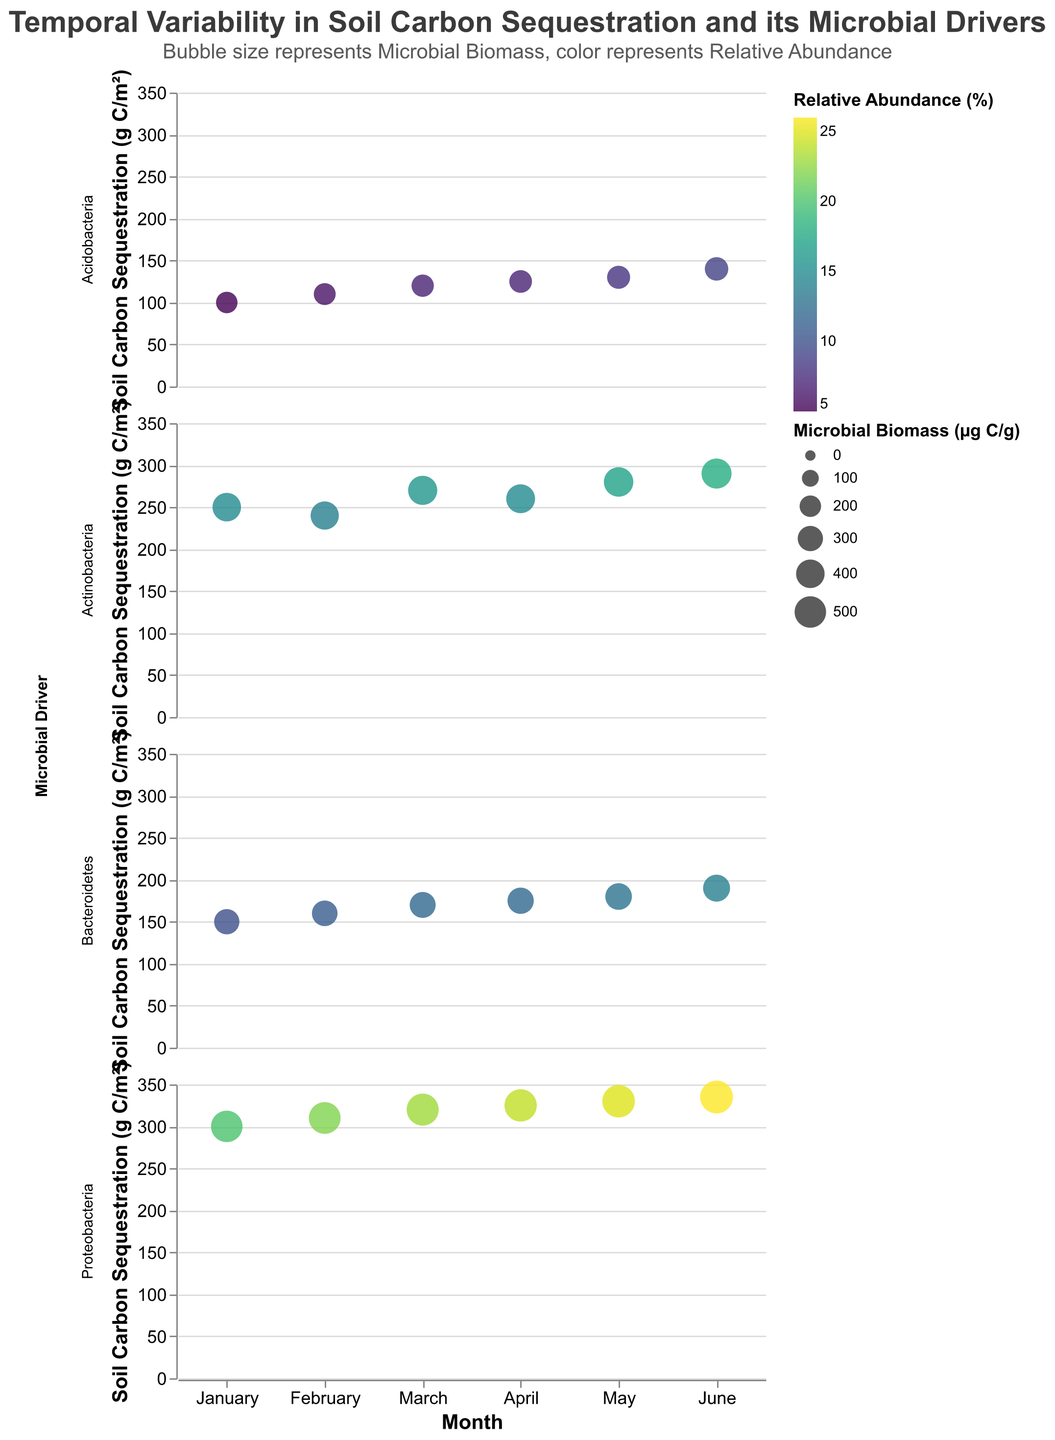What is the title of the figure? The title is prominently placed at the top of the figure. It reads "Temporal Variability in Soil Carbon Sequestration and its Microbial Drivers".
Answer: Temporal Variability in Soil Carbon Sequestration and its Microbial Drivers How is microbial biomass represented in the figure? Microbial biomass is represented by the size of the bubbles in each subplot. Larger bubbles indicate higher microbial biomass values.
Answer: Size of the bubbles Which microbial driver shows the highest soil carbon sequestration in June? By looking at the uppermost points on the y-axis (Soil Carbon Sequestration), the Proteobacteria subplot has the highest point in June, indicating the highest soil carbon sequestration.
Answer: Proteobacteria What is the range of the relative abundance percentage in this figure? The legend for color coding indicates that the relative abundance ranges from 5% to 26%. This range is spanned by the color gradient, from the lightest to the darkest shade.
Answer: 5% to 26% What months show an increase in soil carbon sequestration for Bacteroidetes? By observing the Bacteroidetes subplot, soil carbon sequestration values increase monthly from January through June. The values for each month are 150, 160, 170, 175, 180, and 190 g C/m² respectively.
Answer: January to June Compare the soil carbon sequestration of Actinobacteria and Acidobacteria in March. In March, Actinobacteria has a soil carbon sequestration of 270 g C/m², while Acidobacteria has a value of 120 g C/m². Actinobacteria has a higher value.
Answer: Actinobacteria What is the average soil carbon sequestration for Proteobacteria across all months? Add the soil carbon sequestration values for each month for Proteobacteria (300, 310, 320, 325, 330, 335) which sums to 1920 g C/m². Divide by 6 months to find the average (1920/6).
Answer: 320 g C/m² Which microbial driver has the least variation in relative abundance over the months? By observing the color consistency of the bubbles, Acidobacteria appears to have the least variation in color over the months, indicating minimal relative abundance variation.
Answer: Acidobacteria Explain the relationship between microbial biomass and soil carbon sequestration for Actinobacteria. For Actinobacteria, as the microbial biomass (indicated by bubble size) increases from January (small bubble) to June (largest bubble), the soil carbon sequestration values also generally increase, suggesting a positive relationship.
Answer: Positive relationship 